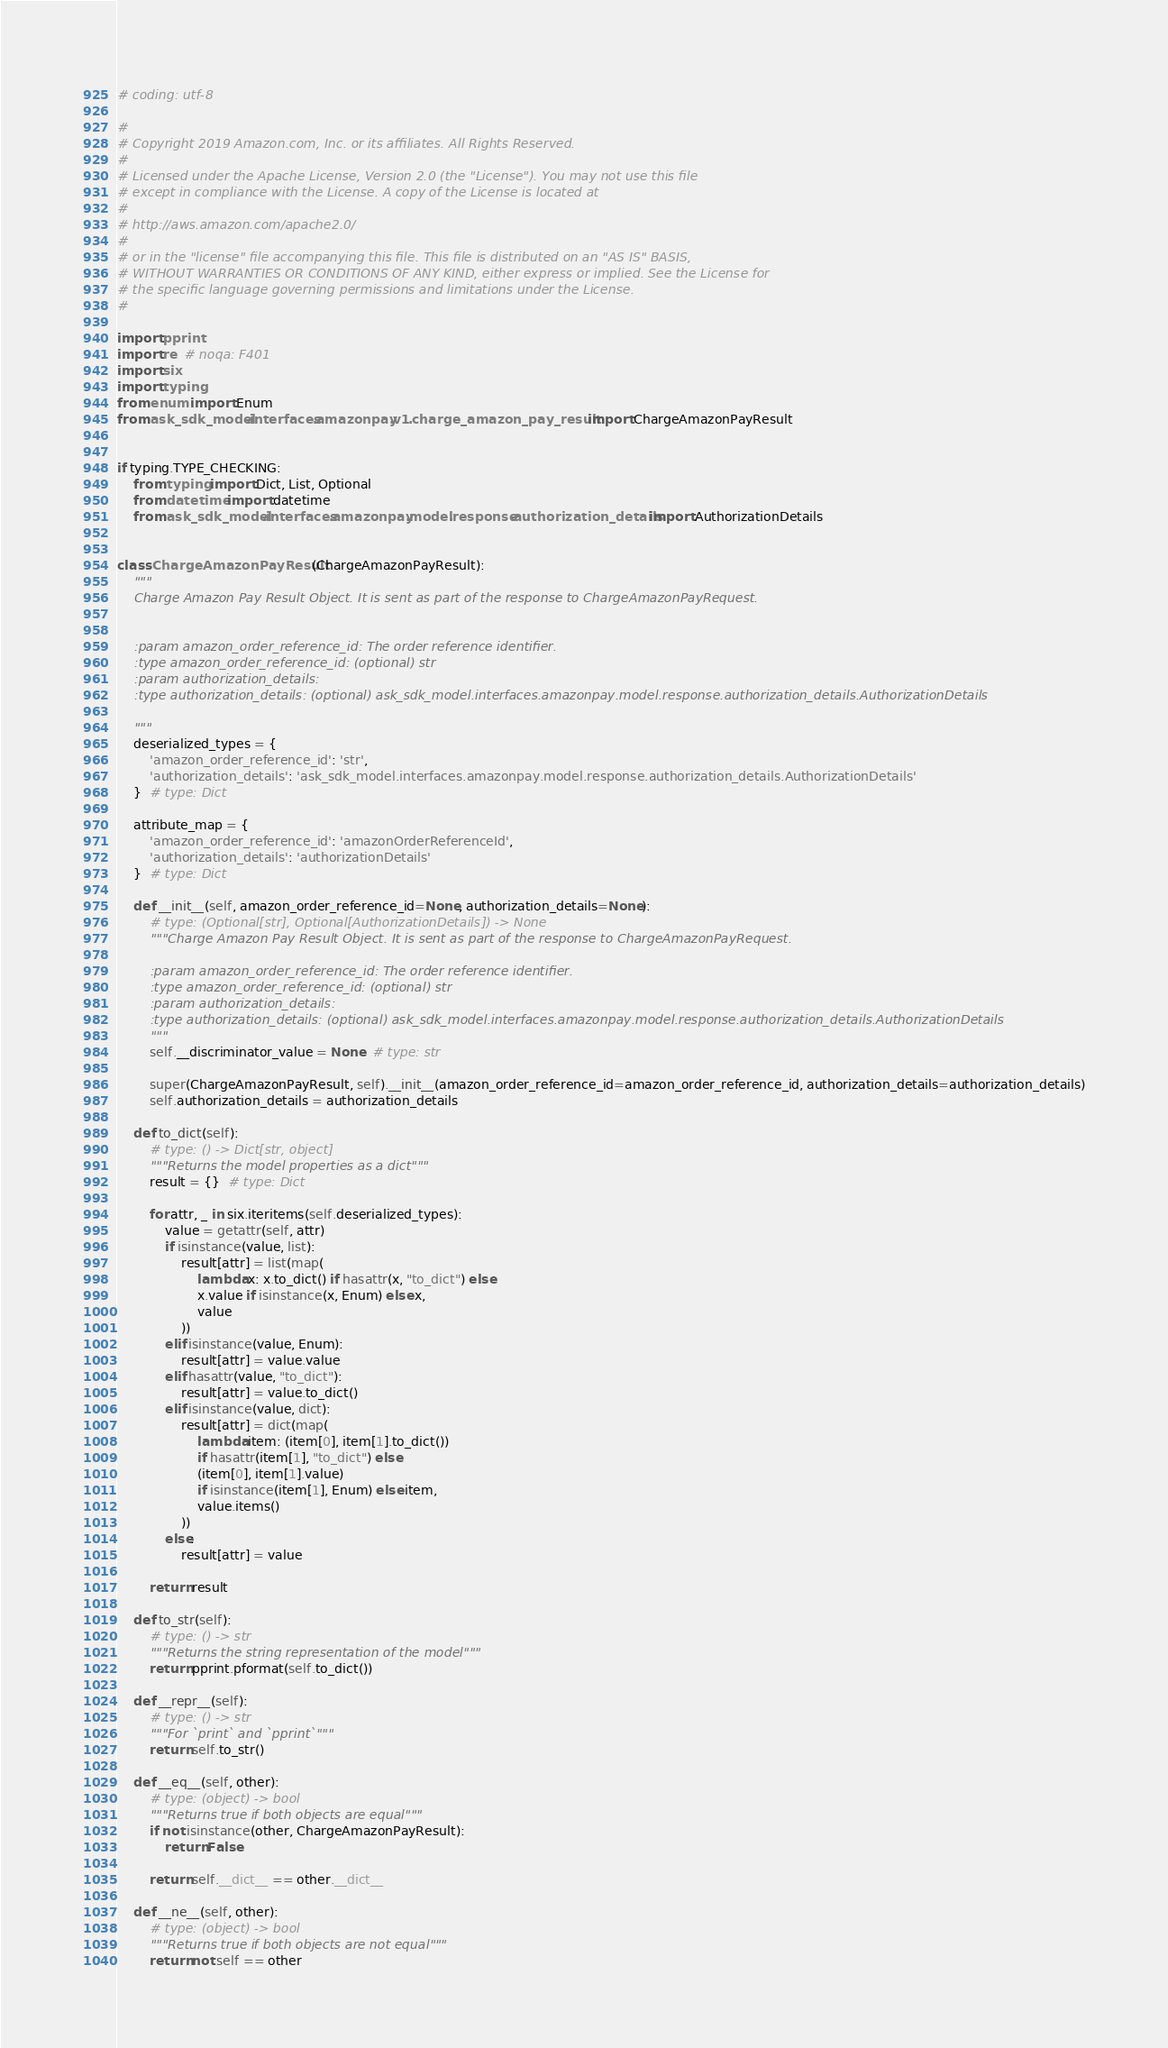Convert code to text. <code><loc_0><loc_0><loc_500><loc_500><_Python_># coding: utf-8

#
# Copyright 2019 Amazon.com, Inc. or its affiliates. All Rights Reserved.
#
# Licensed under the Apache License, Version 2.0 (the "License"). You may not use this file
# except in compliance with the License. A copy of the License is located at
#
# http://aws.amazon.com/apache2.0/
#
# or in the "license" file accompanying this file. This file is distributed on an "AS IS" BASIS,
# WITHOUT WARRANTIES OR CONDITIONS OF ANY KIND, either express or implied. See the License for
# the specific language governing permissions and limitations under the License.
#

import pprint
import re  # noqa: F401
import six
import typing
from enum import Enum
from ask_sdk_model.interfaces.amazonpay.v1.charge_amazon_pay_result import ChargeAmazonPayResult


if typing.TYPE_CHECKING:
    from typing import Dict, List, Optional
    from datetime import datetime
    from ask_sdk_model.interfaces.amazonpay.model.response.authorization_details import AuthorizationDetails


class ChargeAmazonPayResult(ChargeAmazonPayResult):
    """
    Charge Amazon Pay Result Object. It is sent as part of the response to ChargeAmazonPayRequest.


    :param amazon_order_reference_id: The order reference identifier.
    :type amazon_order_reference_id: (optional) str
    :param authorization_details: 
    :type authorization_details: (optional) ask_sdk_model.interfaces.amazonpay.model.response.authorization_details.AuthorizationDetails

    """
    deserialized_types = {
        'amazon_order_reference_id': 'str',
        'authorization_details': 'ask_sdk_model.interfaces.amazonpay.model.response.authorization_details.AuthorizationDetails'
    }  # type: Dict

    attribute_map = {
        'amazon_order_reference_id': 'amazonOrderReferenceId',
        'authorization_details': 'authorizationDetails'
    }  # type: Dict

    def __init__(self, amazon_order_reference_id=None, authorization_details=None):
        # type: (Optional[str], Optional[AuthorizationDetails]) -> None
        """Charge Amazon Pay Result Object. It is sent as part of the response to ChargeAmazonPayRequest.

        :param amazon_order_reference_id: The order reference identifier.
        :type amazon_order_reference_id: (optional) str
        :param authorization_details: 
        :type authorization_details: (optional) ask_sdk_model.interfaces.amazonpay.model.response.authorization_details.AuthorizationDetails
        """
        self.__discriminator_value = None  # type: str

        super(ChargeAmazonPayResult, self).__init__(amazon_order_reference_id=amazon_order_reference_id, authorization_details=authorization_details)
        self.authorization_details = authorization_details

    def to_dict(self):
        # type: () -> Dict[str, object]
        """Returns the model properties as a dict"""
        result = {}  # type: Dict

        for attr, _ in six.iteritems(self.deserialized_types):
            value = getattr(self, attr)
            if isinstance(value, list):
                result[attr] = list(map(
                    lambda x: x.to_dict() if hasattr(x, "to_dict") else
                    x.value if isinstance(x, Enum) else x,
                    value
                ))
            elif isinstance(value, Enum):
                result[attr] = value.value
            elif hasattr(value, "to_dict"):
                result[attr] = value.to_dict()
            elif isinstance(value, dict):
                result[attr] = dict(map(
                    lambda item: (item[0], item[1].to_dict())
                    if hasattr(item[1], "to_dict") else
                    (item[0], item[1].value)
                    if isinstance(item[1], Enum) else item,
                    value.items()
                ))
            else:
                result[attr] = value

        return result

    def to_str(self):
        # type: () -> str
        """Returns the string representation of the model"""
        return pprint.pformat(self.to_dict())

    def __repr__(self):
        # type: () -> str
        """For `print` and `pprint`"""
        return self.to_str()

    def __eq__(self, other):
        # type: (object) -> bool
        """Returns true if both objects are equal"""
        if not isinstance(other, ChargeAmazonPayResult):
            return False

        return self.__dict__ == other.__dict__

    def __ne__(self, other):
        # type: (object) -> bool
        """Returns true if both objects are not equal"""
        return not self == other
</code> 